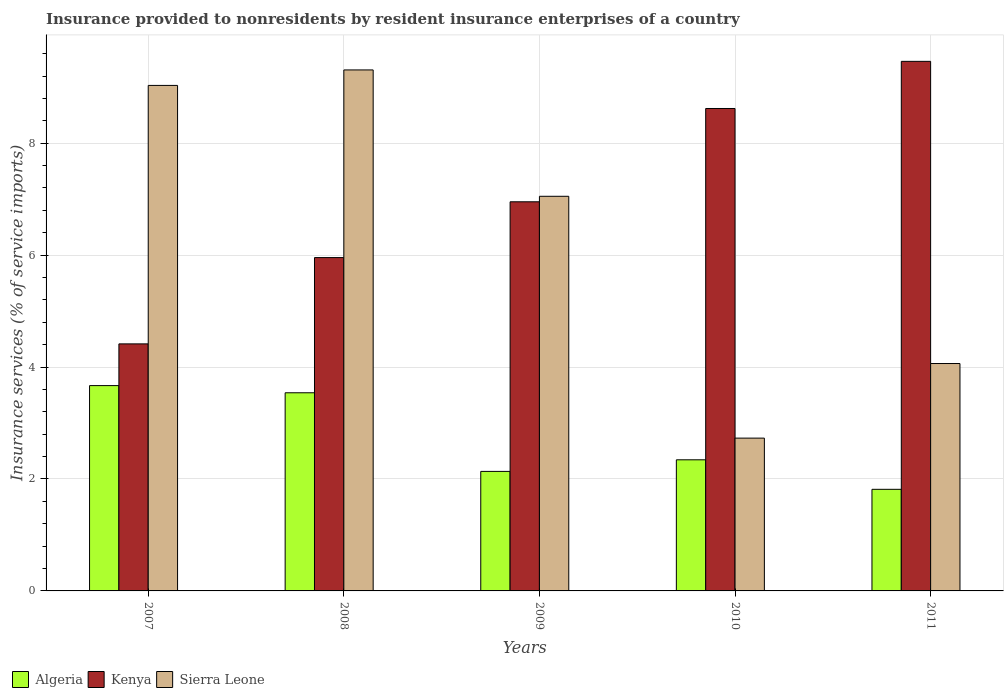Are the number of bars on each tick of the X-axis equal?
Make the answer very short. Yes. How many bars are there on the 1st tick from the right?
Provide a short and direct response. 3. What is the label of the 4th group of bars from the left?
Provide a succinct answer. 2010. What is the insurance provided to nonresidents in Kenya in 2010?
Offer a terse response. 8.62. Across all years, what is the maximum insurance provided to nonresidents in Sierra Leone?
Your answer should be very brief. 9.31. Across all years, what is the minimum insurance provided to nonresidents in Sierra Leone?
Provide a succinct answer. 2.73. What is the total insurance provided to nonresidents in Algeria in the graph?
Provide a short and direct response. 13.5. What is the difference between the insurance provided to nonresidents in Kenya in 2007 and that in 2011?
Your answer should be very brief. -5.05. What is the difference between the insurance provided to nonresidents in Kenya in 2008 and the insurance provided to nonresidents in Sierra Leone in 2010?
Offer a very short reply. 3.23. What is the average insurance provided to nonresidents in Kenya per year?
Ensure brevity in your answer.  7.08. In the year 2010, what is the difference between the insurance provided to nonresidents in Sierra Leone and insurance provided to nonresidents in Algeria?
Your answer should be compact. 0.39. What is the ratio of the insurance provided to nonresidents in Algeria in 2007 to that in 2008?
Your answer should be very brief. 1.04. Is the difference between the insurance provided to nonresidents in Sierra Leone in 2010 and 2011 greater than the difference between the insurance provided to nonresidents in Algeria in 2010 and 2011?
Offer a terse response. No. What is the difference between the highest and the second highest insurance provided to nonresidents in Algeria?
Keep it short and to the point. 0.13. What is the difference between the highest and the lowest insurance provided to nonresidents in Algeria?
Keep it short and to the point. 1.85. What does the 3rd bar from the left in 2011 represents?
Make the answer very short. Sierra Leone. What does the 2nd bar from the right in 2009 represents?
Keep it short and to the point. Kenya. Is it the case that in every year, the sum of the insurance provided to nonresidents in Kenya and insurance provided to nonresidents in Sierra Leone is greater than the insurance provided to nonresidents in Algeria?
Your answer should be very brief. Yes. Are all the bars in the graph horizontal?
Your response must be concise. No. What is the difference between two consecutive major ticks on the Y-axis?
Give a very brief answer. 2. Are the values on the major ticks of Y-axis written in scientific E-notation?
Give a very brief answer. No. Does the graph contain any zero values?
Your answer should be very brief. No. Does the graph contain grids?
Offer a terse response. Yes. Where does the legend appear in the graph?
Provide a short and direct response. Bottom left. How are the legend labels stacked?
Your response must be concise. Horizontal. What is the title of the graph?
Provide a succinct answer. Insurance provided to nonresidents by resident insurance enterprises of a country. Does "Egypt, Arab Rep." appear as one of the legend labels in the graph?
Give a very brief answer. No. What is the label or title of the Y-axis?
Your response must be concise. Insurance services (% of service imports). What is the Insurance services (% of service imports) of Algeria in 2007?
Offer a very short reply. 3.67. What is the Insurance services (% of service imports) in Kenya in 2007?
Offer a very short reply. 4.41. What is the Insurance services (% of service imports) in Sierra Leone in 2007?
Ensure brevity in your answer.  9.03. What is the Insurance services (% of service imports) of Algeria in 2008?
Provide a short and direct response. 3.54. What is the Insurance services (% of service imports) in Kenya in 2008?
Offer a very short reply. 5.96. What is the Insurance services (% of service imports) of Sierra Leone in 2008?
Your answer should be very brief. 9.31. What is the Insurance services (% of service imports) in Algeria in 2009?
Offer a terse response. 2.14. What is the Insurance services (% of service imports) in Kenya in 2009?
Provide a succinct answer. 6.95. What is the Insurance services (% of service imports) in Sierra Leone in 2009?
Give a very brief answer. 7.05. What is the Insurance services (% of service imports) of Algeria in 2010?
Provide a short and direct response. 2.34. What is the Insurance services (% of service imports) in Kenya in 2010?
Provide a succinct answer. 8.62. What is the Insurance services (% of service imports) in Sierra Leone in 2010?
Offer a terse response. 2.73. What is the Insurance services (% of service imports) in Algeria in 2011?
Provide a succinct answer. 1.82. What is the Insurance services (% of service imports) in Kenya in 2011?
Your response must be concise. 9.46. What is the Insurance services (% of service imports) in Sierra Leone in 2011?
Offer a terse response. 4.06. Across all years, what is the maximum Insurance services (% of service imports) in Algeria?
Your answer should be compact. 3.67. Across all years, what is the maximum Insurance services (% of service imports) in Kenya?
Give a very brief answer. 9.46. Across all years, what is the maximum Insurance services (% of service imports) of Sierra Leone?
Offer a very short reply. 9.31. Across all years, what is the minimum Insurance services (% of service imports) in Algeria?
Your response must be concise. 1.82. Across all years, what is the minimum Insurance services (% of service imports) of Kenya?
Your response must be concise. 4.41. Across all years, what is the minimum Insurance services (% of service imports) of Sierra Leone?
Your response must be concise. 2.73. What is the total Insurance services (% of service imports) in Algeria in the graph?
Offer a terse response. 13.5. What is the total Insurance services (% of service imports) of Kenya in the graph?
Your response must be concise. 35.4. What is the total Insurance services (% of service imports) of Sierra Leone in the graph?
Your response must be concise. 32.19. What is the difference between the Insurance services (% of service imports) in Algeria in 2007 and that in 2008?
Provide a short and direct response. 0.13. What is the difference between the Insurance services (% of service imports) in Kenya in 2007 and that in 2008?
Your response must be concise. -1.54. What is the difference between the Insurance services (% of service imports) in Sierra Leone in 2007 and that in 2008?
Your response must be concise. -0.28. What is the difference between the Insurance services (% of service imports) of Algeria in 2007 and that in 2009?
Ensure brevity in your answer.  1.53. What is the difference between the Insurance services (% of service imports) of Kenya in 2007 and that in 2009?
Ensure brevity in your answer.  -2.54. What is the difference between the Insurance services (% of service imports) in Sierra Leone in 2007 and that in 2009?
Offer a terse response. 1.98. What is the difference between the Insurance services (% of service imports) of Algeria in 2007 and that in 2010?
Keep it short and to the point. 1.33. What is the difference between the Insurance services (% of service imports) of Kenya in 2007 and that in 2010?
Your answer should be very brief. -4.21. What is the difference between the Insurance services (% of service imports) in Sierra Leone in 2007 and that in 2010?
Your answer should be very brief. 6.3. What is the difference between the Insurance services (% of service imports) of Algeria in 2007 and that in 2011?
Your answer should be very brief. 1.85. What is the difference between the Insurance services (% of service imports) in Kenya in 2007 and that in 2011?
Give a very brief answer. -5.05. What is the difference between the Insurance services (% of service imports) of Sierra Leone in 2007 and that in 2011?
Offer a very short reply. 4.97. What is the difference between the Insurance services (% of service imports) of Algeria in 2008 and that in 2009?
Ensure brevity in your answer.  1.41. What is the difference between the Insurance services (% of service imports) in Kenya in 2008 and that in 2009?
Ensure brevity in your answer.  -1. What is the difference between the Insurance services (% of service imports) of Sierra Leone in 2008 and that in 2009?
Give a very brief answer. 2.26. What is the difference between the Insurance services (% of service imports) in Algeria in 2008 and that in 2010?
Your response must be concise. 1.2. What is the difference between the Insurance services (% of service imports) in Kenya in 2008 and that in 2010?
Your answer should be very brief. -2.66. What is the difference between the Insurance services (% of service imports) of Sierra Leone in 2008 and that in 2010?
Ensure brevity in your answer.  6.58. What is the difference between the Insurance services (% of service imports) in Algeria in 2008 and that in 2011?
Provide a succinct answer. 1.73. What is the difference between the Insurance services (% of service imports) of Kenya in 2008 and that in 2011?
Offer a terse response. -3.51. What is the difference between the Insurance services (% of service imports) in Sierra Leone in 2008 and that in 2011?
Your response must be concise. 5.25. What is the difference between the Insurance services (% of service imports) of Algeria in 2009 and that in 2010?
Provide a succinct answer. -0.21. What is the difference between the Insurance services (% of service imports) in Kenya in 2009 and that in 2010?
Offer a terse response. -1.67. What is the difference between the Insurance services (% of service imports) of Sierra Leone in 2009 and that in 2010?
Offer a terse response. 4.32. What is the difference between the Insurance services (% of service imports) of Algeria in 2009 and that in 2011?
Provide a succinct answer. 0.32. What is the difference between the Insurance services (% of service imports) in Kenya in 2009 and that in 2011?
Keep it short and to the point. -2.51. What is the difference between the Insurance services (% of service imports) in Sierra Leone in 2009 and that in 2011?
Provide a short and direct response. 2.99. What is the difference between the Insurance services (% of service imports) in Algeria in 2010 and that in 2011?
Ensure brevity in your answer.  0.53. What is the difference between the Insurance services (% of service imports) of Kenya in 2010 and that in 2011?
Give a very brief answer. -0.84. What is the difference between the Insurance services (% of service imports) of Sierra Leone in 2010 and that in 2011?
Make the answer very short. -1.33. What is the difference between the Insurance services (% of service imports) of Algeria in 2007 and the Insurance services (% of service imports) of Kenya in 2008?
Provide a succinct answer. -2.29. What is the difference between the Insurance services (% of service imports) of Algeria in 2007 and the Insurance services (% of service imports) of Sierra Leone in 2008?
Make the answer very short. -5.64. What is the difference between the Insurance services (% of service imports) of Kenya in 2007 and the Insurance services (% of service imports) of Sierra Leone in 2008?
Offer a very short reply. -4.89. What is the difference between the Insurance services (% of service imports) of Algeria in 2007 and the Insurance services (% of service imports) of Kenya in 2009?
Offer a terse response. -3.28. What is the difference between the Insurance services (% of service imports) in Algeria in 2007 and the Insurance services (% of service imports) in Sierra Leone in 2009?
Offer a very short reply. -3.38. What is the difference between the Insurance services (% of service imports) in Kenya in 2007 and the Insurance services (% of service imports) in Sierra Leone in 2009?
Ensure brevity in your answer.  -2.64. What is the difference between the Insurance services (% of service imports) of Algeria in 2007 and the Insurance services (% of service imports) of Kenya in 2010?
Your answer should be very brief. -4.95. What is the difference between the Insurance services (% of service imports) in Algeria in 2007 and the Insurance services (% of service imports) in Sierra Leone in 2010?
Provide a succinct answer. 0.94. What is the difference between the Insurance services (% of service imports) in Kenya in 2007 and the Insurance services (% of service imports) in Sierra Leone in 2010?
Make the answer very short. 1.68. What is the difference between the Insurance services (% of service imports) of Algeria in 2007 and the Insurance services (% of service imports) of Kenya in 2011?
Provide a short and direct response. -5.79. What is the difference between the Insurance services (% of service imports) of Algeria in 2007 and the Insurance services (% of service imports) of Sierra Leone in 2011?
Your response must be concise. -0.39. What is the difference between the Insurance services (% of service imports) in Kenya in 2007 and the Insurance services (% of service imports) in Sierra Leone in 2011?
Your response must be concise. 0.35. What is the difference between the Insurance services (% of service imports) of Algeria in 2008 and the Insurance services (% of service imports) of Kenya in 2009?
Your response must be concise. -3.41. What is the difference between the Insurance services (% of service imports) in Algeria in 2008 and the Insurance services (% of service imports) in Sierra Leone in 2009?
Offer a terse response. -3.51. What is the difference between the Insurance services (% of service imports) in Kenya in 2008 and the Insurance services (% of service imports) in Sierra Leone in 2009?
Make the answer very short. -1.1. What is the difference between the Insurance services (% of service imports) in Algeria in 2008 and the Insurance services (% of service imports) in Kenya in 2010?
Your answer should be very brief. -5.08. What is the difference between the Insurance services (% of service imports) of Algeria in 2008 and the Insurance services (% of service imports) of Sierra Leone in 2010?
Keep it short and to the point. 0.81. What is the difference between the Insurance services (% of service imports) in Kenya in 2008 and the Insurance services (% of service imports) in Sierra Leone in 2010?
Your answer should be compact. 3.23. What is the difference between the Insurance services (% of service imports) in Algeria in 2008 and the Insurance services (% of service imports) in Kenya in 2011?
Ensure brevity in your answer.  -5.92. What is the difference between the Insurance services (% of service imports) in Algeria in 2008 and the Insurance services (% of service imports) in Sierra Leone in 2011?
Make the answer very short. -0.52. What is the difference between the Insurance services (% of service imports) of Kenya in 2008 and the Insurance services (% of service imports) of Sierra Leone in 2011?
Your answer should be compact. 1.89. What is the difference between the Insurance services (% of service imports) in Algeria in 2009 and the Insurance services (% of service imports) in Kenya in 2010?
Offer a very short reply. -6.48. What is the difference between the Insurance services (% of service imports) in Algeria in 2009 and the Insurance services (% of service imports) in Sierra Leone in 2010?
Provide a succinct answer. -0.59. What is the difference between the Insurance services (% of service imports) in Kenya in 2009 and the Insurance services (% of service imports) in Sierra Leone in 2010?
Your response must be concise. 4.22. What is the difference between the Insurance services (% of service imports) in Algeria in 2009 and the Insurance services (% of service imports) in Kenya in 2011?
Give a very brief answer. -7.33. What is the difference between the Insurance services (% of service imports) of Algeria in 2009 and the Insurance services (% of service imports) of Sierra Leone in 2011?
Provide a succinct answer. -1.93. What is the difference between the Insurance services (% of service imports) in Kenya in 2009 and the Insurance services (% of service imports) in Sierra Leone in 2011?
Your answer should be compact. 2.89. What is the difference between the Insurance services (% of service imports) of Algeria in 2010 and the Insurance services (% of service imports) of Kenya in 2011?
Offer a very short reply. -7.12. What is the difference between the Insurance services (% of service imports) of Algeria in 2010 and the Insurance services (% of service imports) of Sierra Leone in 2011?
Your answer should be very brief. -1.72. What is the difference between the Insurance services (% of service imports) of Kenya in 2010 and the Insurance services (% of service imports) of Sierra Leone in 2011?
Your response must be concise. 4.56. What is the average Insurance services (% of service imports) in Algeria per year?
Provide a short and direct response. 2.7. What is the average Insurance services (% of service imports) in Kenya per year?
Your response must be concise. 7.08. What is the average Insurance services (% of service imports) of Sierra Leone per year?
Provide a short and direct response. 6.44. In the year 2007, what is the difference between the Insurance services (% of service imports) of Algeria and Insurance services (% of service imports) of Kenya?
Make the answer very short. -0.75. In the year 2007, what is the difference between the Insurance services (% of service imports) of Algeria and Insurance services (% of service imports) of Sierra Leone?
Provide a succinct answer. -5.36. In the year 2007, what is the difference between the Insurance services (% of service imports) in Kenya and Insurance services (% of service imports) in Sierra Leone?
Provide a succinct answer. -4.62. In the year 2008, what is the difference between the Insurance services (% of service imports) of Algeria and Insurance services (% of service imports) of Kenya?
Your answer should be very brief. -2.42. In the year 2008, what is the difference between the Insurance services (% of service imports) of Algeria and Insurance services (% of service imports) of Sierra Leone?
Offer a terse response. -5.77. In the year 2008, what is the difference between the Insurance services (% of service imports) of Kenya and Insurance services (% of service imports) of Sierra Leone?
Make the answer very short. -3.35. In the year 2009, what is the difference between the Insurance services (% of service imports) of Algeria and Insurance services (% of service imports) of Kenya?
Ensure brevity in your answer.  -4.82. In the year 2009, what is the difference between the Insurance services (% of service imports) of Algeria and Insurance services (% of service imports) of Sierra Leone?
Your response must be concise. -4.92. In the year 2009, what is the difference between the Insurance services (% of service imports) in Kenya and Insurance services (% of service imports) in Sierra Leone?
Make the answer very short. -0.1. In the year 2010, what is the difference between the Insurance services (% of service imports) in Algeria and Insurance services (% of service imports) in Kenya?
Ensure brevity in your answer.  -6.28. In the year 2010, what is the difference between the Insurance services (% of service imports) in Algeria and Insurance services (% of service imports) in Sierra Leone?
Give a very brief answer. -0.39. In the year 2010, what is the difference between the Insurance services (% of service imports) of Kenya and Insurance services (% of service imports) of Sierra Leone?
Your answer should be very brief. 5.89. In the year 2011, what is the difference between the Insurance services (% of service imports) in Algeria and Insurance services (% of service imports) in Kenya?
Provide a succinct answer. -7.65. In the year 2011, what is the difference between the Insurance services (% of service imports) of Algeria and Insurance services (% of service imports) of Sierra Leone?
Your answer should be very brief. -2.25. In the year 2011, what is the difference between the Insurance services (% of service imports) in Kenya and Insurance services (% of service imports) in Sierra Leone?
Provide a succinct answer. 5.4. What is the ratio of the Insurance services (% of service imports) in Algeria in 2007 to that in 2008?
Provide a succinct answer. 1.04. What is the ratio of the Insurance services (% of service imports) in Kenya in 2007 to that in 2008?
Offer a terse response. 0.74. What is the ratio of the Insurance services (% of service imports) in Sierra Leone in 2007 to that in 2008?
Your response must be concise. 0.97. What is the ratio of the Insurance services (% of service imports) in Algeria in 2007 to that in 2009?
Offer a terse response. 1.72. What is the ratio of the Insurance services (% of service imports) in Kenya in 2007 to that in 2009?
Offer a terse response. 0.63. What is the ratio of the Insurance services (% of service imports) of Sierra Leone in 2007 to that in 2009?
Offer a very short reply. 1.28. What is the ratio of the Insurance services (% of service imports) in Algeria in 2007 to that in 2010?
Make the answer very short. 1.57. What is the ratio of the Insurance services (% of service imports) in Kenya in 2007 to that in 2010?
Your answer should be very brief. 0.51. What is the ratio of the Insurance services (% of service imports) of Sierra Leone in 2007 to that in 2010?
Keep it short and to the point. 3.31. What is the ratio of the Insurance services (% of service imports) in Algeria in 2007 to that in 2011?
Make the answer very short. 2.02. What is the ratio of the Insurance services (% of service imports) of Kenya in 2007 to that in 2011?
Your response must be concise. 0.47. What is the ratio of the Insurance services (% of service imports) of Sierra Leone in 2007 to that in 2011?
Your answer should be very brief. 2.22. What is the ratio of the Insurance services (% of service imports) of Algeria in 2008 to that in 2009?
Your answer should be compact. 1.66. What is the ratio of the Insurance services (% of service imports) of Kenya in 2008 to that in 2009?
Provide a short and direct response. 0.86. What is the ratio of the Insurance services (% of service imports) in Sierra Leone in 2008 to that in 2009?
Provide a succinct answer. 1.32. What is the ratio of the Insurance services (% of service imports) in Algeria in 2008 to that in 2010?
Your answer should be compact. 1.51. What is the ratio of the Insurance services (% of service imports) in Kenya in 2008 to that in 2010?
Ensure brevity in your answer.  0.69. What is the ratio of the Insurance services (% of service imports) in Sierra Leone in 2008 to that in 2010?
Offer a very short reply. 3.41. What is the ratio of the Insurance services (% of service imports) in Algeria in 2008 to that in 2011?
Offer a very short reply. 1.95. What is the ratio of the Insurance services (% of service imports) in Kenya in 2008 to that in 2011?
Give a very brief answer. 0.63. What is the ratio of the Insurance services (% of service imports) of Sierra Leone in 2008 to that in 2011?
Your answer should be very brief. 2.29. What is the ratio of the Insurance services (% of service imports) of Algeria in 2009 to that in 2010?
Ensure brevity in your answer.  0.91. What is the ratio of the Insurance services (% of service imports) in Kenya in 2009 to that in 2010?
Offer a terse response. 0.81. What is the ratio of the Insurance services (% of service imports) of Sierra Leone in 2009 to that in 2010?
Provide a succinct answer. 2.58. What is the ratio of the Insurance services (% of service imports) of Algeria in 2009 to that in 2011?
Offer a terse response. 1.18. What is the ratio of the Insurance services (% of service imports) in Kenya in 2009 to that in 2011?
Make the answer very short. 0.73. What is the ratio of the Insurance services (% of service imports) in Sierra Leone in 2009 to that in 2011?
Offer a very short reply. 1.74. What is the ratio of the Insurance services (% of service imports) in Algeria in 2010 to that in 2011?
Your response must be concise. 1.29. What is the ratio of the Insurance services (% of service imports) in Kenya in 2010 to that in 2011?
Your response must be concise. 0.91. What is the ratio of the Insurance services (% of service imports) of Sierra Leone in 2010 to that in 2011?
Your response must be concise. 0.67. What is the difference between the highest and the second highest Insurance services (% of service imports) in Algeria?
Offer a very short reply. 0.13. What is the difference between the highest and the second highest Insurance services (% of service imports) in Kenya?
Offer a very short reply. 0.84. What is the difference between the highest and the second highest Insurance services (% of service imports) in Sierra Leone?
Give a very brief answer. 0.28. What is the difference between the highest and the lowest Insurance services (% of service imports) of Algeria?
Ensure brevity in your answer.  1.85. What is the difference between the highest and the lowest Insurance services (% of service imports) in Kenya?
Give a very brief answer. 5.05. What is the difference between the highest and the lowest Insurance services (% of service imports) in Sierra Leone?
Keep it short and to the point. 6.58. 